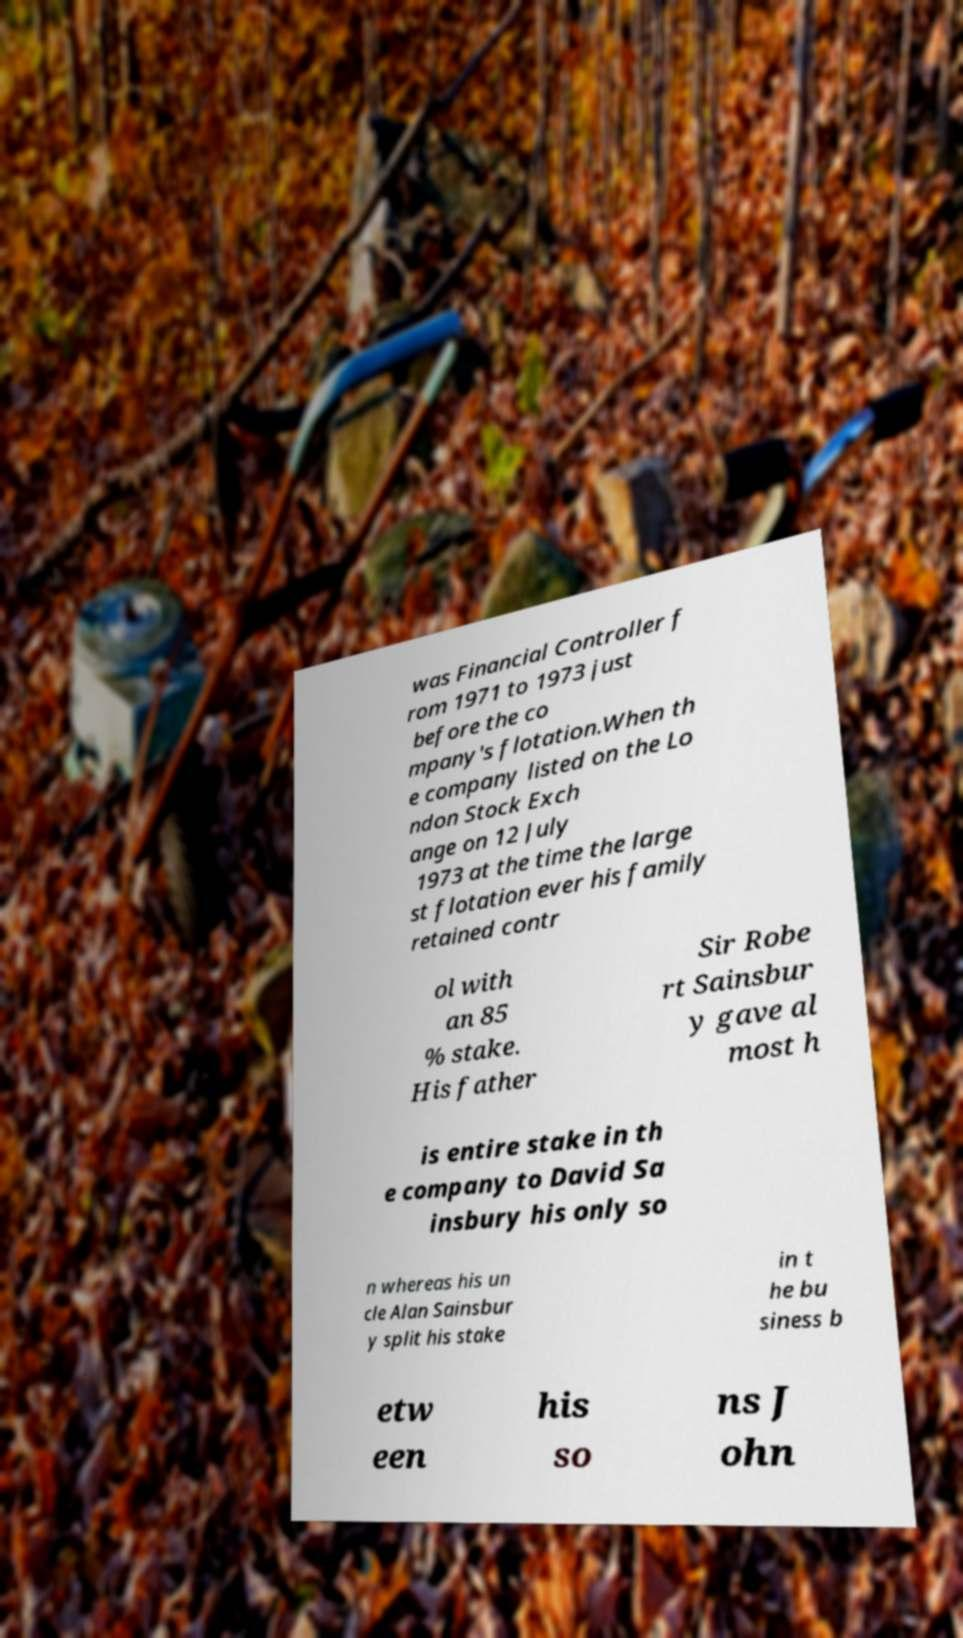Can you read and provide the text displayed in the image?This photo seems to have some interesting text. Can you extract and type it out for me? was Financial Controller f rom 1971 to 1973 just before the co mpany's flotation.When th e company listed on the Lo ndon Stock Exch ange on 12 July 1973 at the time the large st flotation ever his family retained contr ol with an 85 % stake. His father Sir Robe rt Sainsbur y gave al most h is entire stake in th e company to David Sa insbury his only so n whereas his un cle Alan Sainsbur y split his stake in t he bu siness b etw een his so ns J ohn 